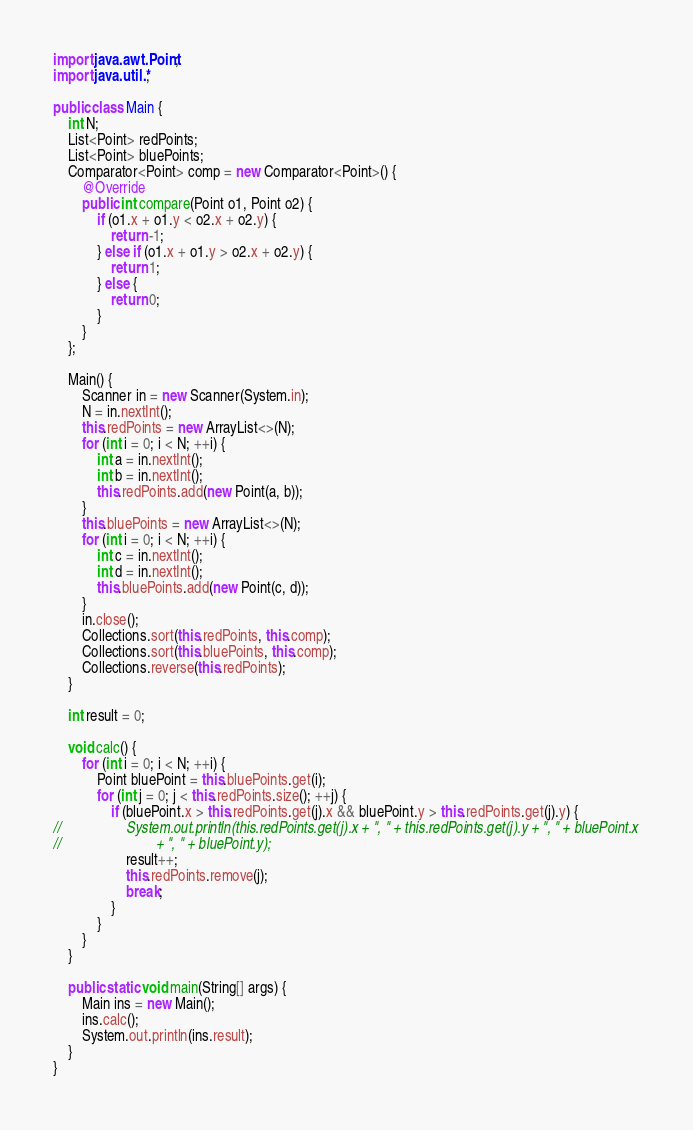<code> <loc_0><loc_0><loc_500><loc_500><_Java_>import java.awt.Point;
import java.util.*;

public class Main {
	int N;
	List<Point> redPoints;
	List<Point> bluePoints;
	Comparator<Point> comp = new Comparator<Point>() {
		@Override
		public int compare(Point o1, Point o2) {
			if (o1.x + o1.y < o2.x + o2.y) {
				return -1;
			} else if (o1.x + o1.y > o2.x + o2.y) {
				return 1;
			} else {
				return 0;
			}
		}
	};

	Main() {
		Scanner in = new Scanner(System.in);
		N = in.nextInt();
		this.redPoints = new ArrayList<>(N);
		for (int i = 0; i < N; ++i) {
			int a = in.nextInt();
			int b = in.nextInt();
			this.redPoints.add(new Point(a, b));
		}
		this.bluePoints = new ArrayList<>(N);
		for (int i = 0; i < N; ++i) {
			int c = in.nextInt();
			int d = in.nextInt();
			this.bluePoints.add(new Point(c, d));
		}
		in.close();
		Collections.sort(this.redPoints, this.comp);
		Collections.sort(this.bluePoints, this.comp);
		Collections.reverse(this.redPoints);
	}

	int result = 0;

	void calc() {
		for (int i = 0; i < N; ++i) {
			Point bluePoint = this.bluePoints.get(i);
			for (int j = 0; j < this.redPoints.size(); ++j) {
				if (bluePoint.x > this.redPoints.get(j).x && bluePoint.y > this.redPoints.get(j).y) {
//					System.out.println(this.redPoints.get(j).x + ", " + this.redPoints.get(j).y + ", " + bluePoint.x
//							+ ", " + bluePoint.y);
					result++;
					this.redPoints.remove(j);
					break;
				}
			}
		}
	}

	public static void main(String[] args) {
		Main ins = new Main();
		ins.calc();
		System.out.println(ins.result);
	}
}
</code> 